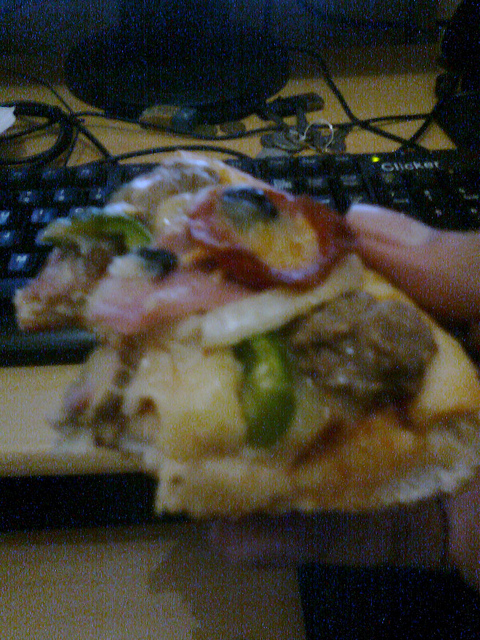Is the person eating cheese pizza? No, the pizza includes a variety of toppings, including pineapple and what looks like ham, along with other vegetables. 